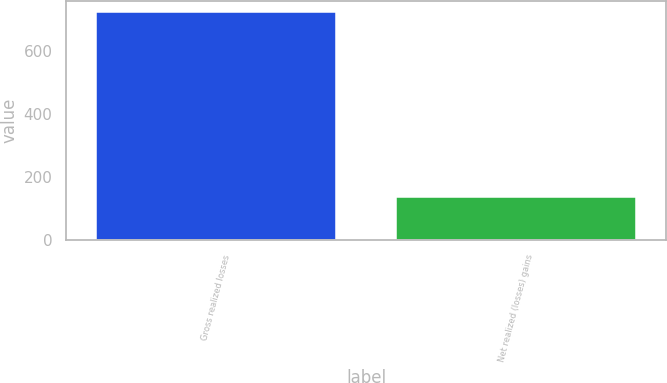<chart> <loc_0><loc_0><loc_500><loc_500><bar_chart><fcel>Gross realized losses<fcel>Net realized (losses) gains<nl><fcel>723<fcel>138<nl></chart> 